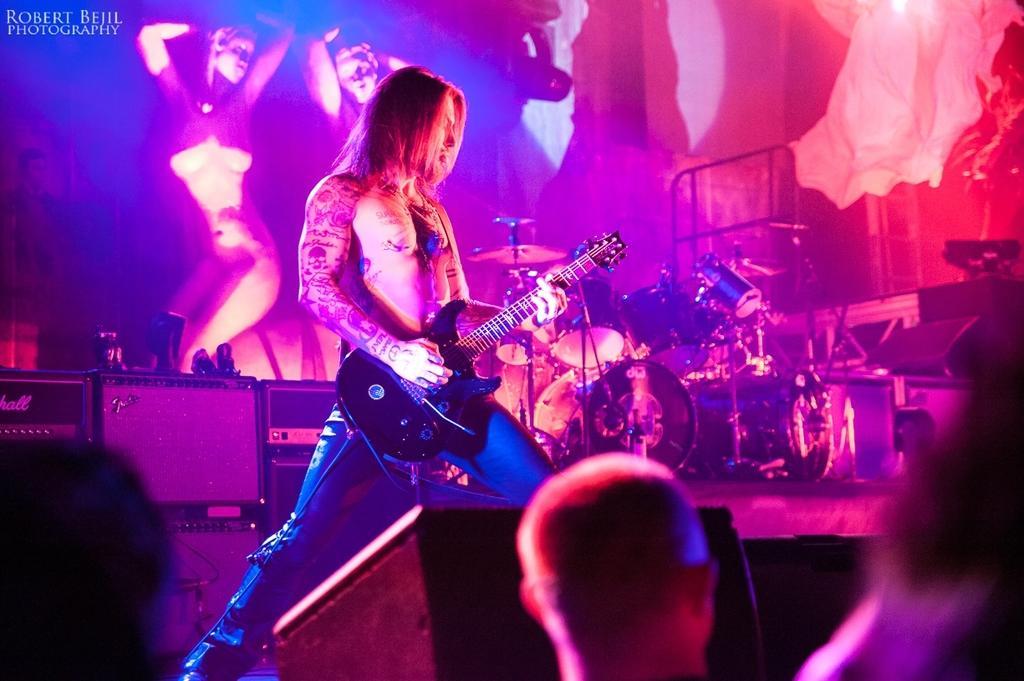Describe this image in one or two sentences. In this image there is a person playing a guitar. In front of him there are few people. Behind him there are musical instruments on the stage. On the left side of the image there are some objects. In the background of the image there is a screen. There is some text on the top left of the image. 